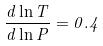Convert formula to latex. <formula><loc_0><loc_0><loc_500><loc_500>\frac { d \ln T } { d \ln P } = 0 . 4</formula> 